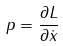<formula> <loc_0><loc_0><loc_500><loc_500>p = \frac { \partial L } { \partial \dot { x } }</formula> 